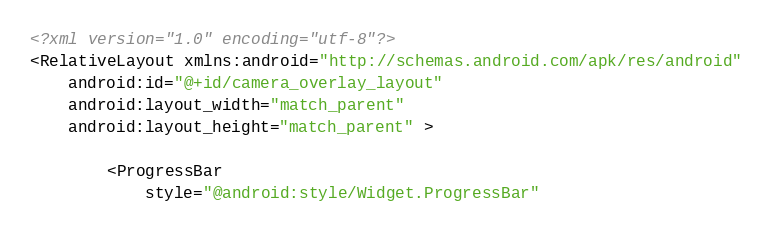Convert code to text. <code><loc_0><loc_0><loc_500><loc_500><_XML_><?xml version="1.0" encoding="utf-8"?>
<RelativeLayout xmlns:android="http://schemas.android.com/apk/res/android"
    android:id="@+id/camera_overlay_layout"
    android:layout_width="match_parent"
    android:layout_height="match_parent" >

        <ProgressBar
            style="@android:style/Widget.ProgressBar"</code> 